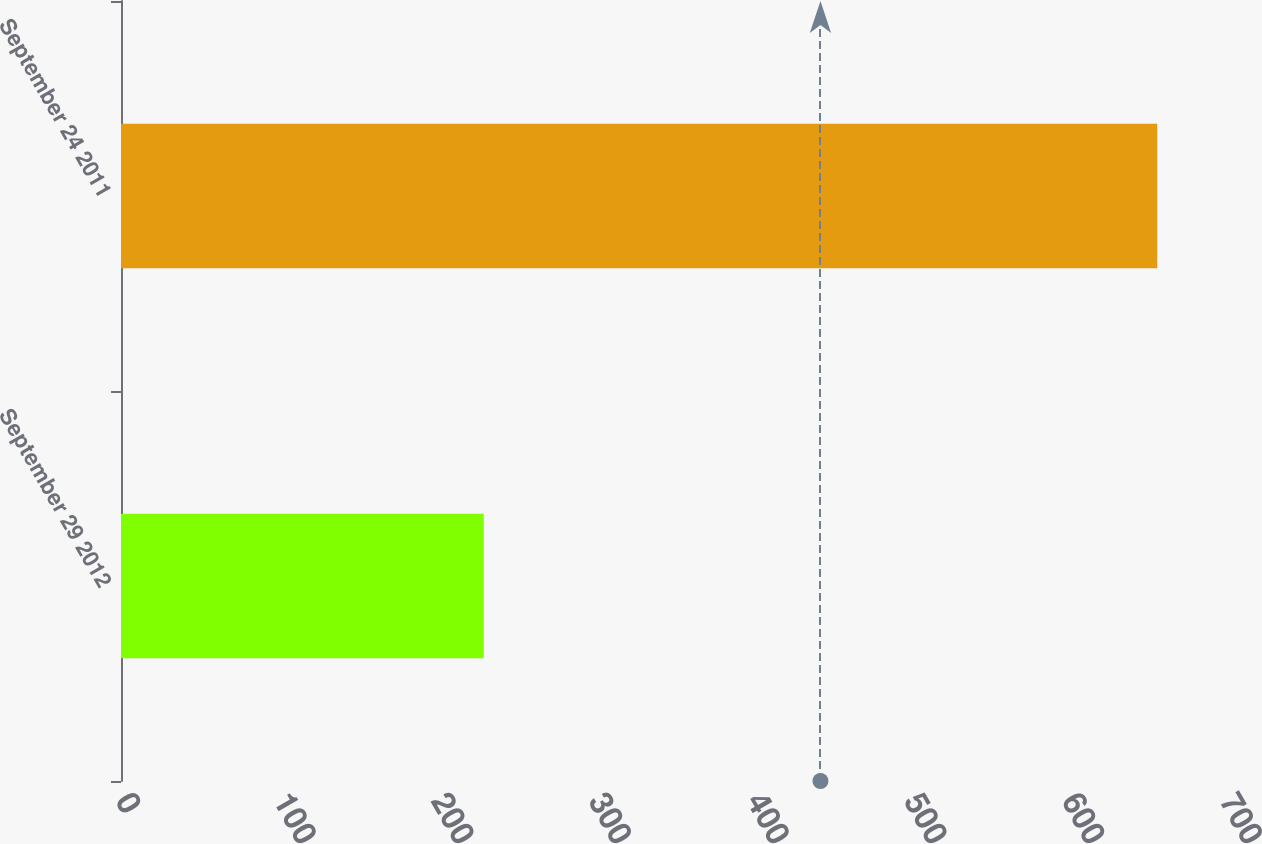Convert chart. <chart><loc_0><loc_0><loc_500><loc_500><bar_chart><fcel>September 29 2012<fcel>September 24 2011<nl><fcel>230<fcel>657<nl></chart> 